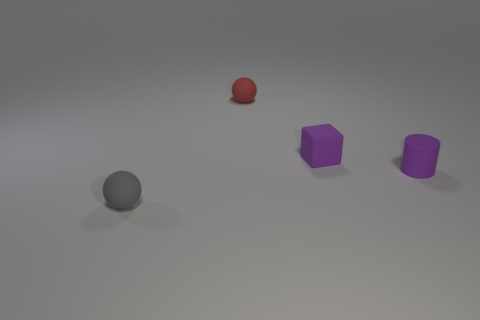Is the purple object that is to the left of the small purple matte cylinder made of the same material as the purple thing that is in front of the cube?
Offer a terse response. Yes. Do the tiny matte cylinder and the matte ball to the right of the tiny gray ball have the same color?
Offer a very short reply. No. What is the shape of the tiny object that is the same color as the rubber block?
Your answer should be compact. Cylinder. Is the color of the cylinder the same as the cube?
Keep it short and to the point. Yes. How many objects are purple rubber objects that are behind the tiny purple cylinder or large yellow spheres?
Provide a succinct answer. 1. There is a gray ball that is made of the same material as the block; what size is it?
Offer a very short reply. Small. Are there more tiny red rubber spheres that are in front of the small cylinder than gray balls?
Offer a terse response. No. There is a small red matte thing; is its shape the same as the thing on the left side of the red ball?
Offer a very short reply. Yes. How many small things are cubes or cylinders?
Keep it short and to the point. 2. What size is the rubber thing that is the same color as the cube?
Keep it short and to the point. Small. 